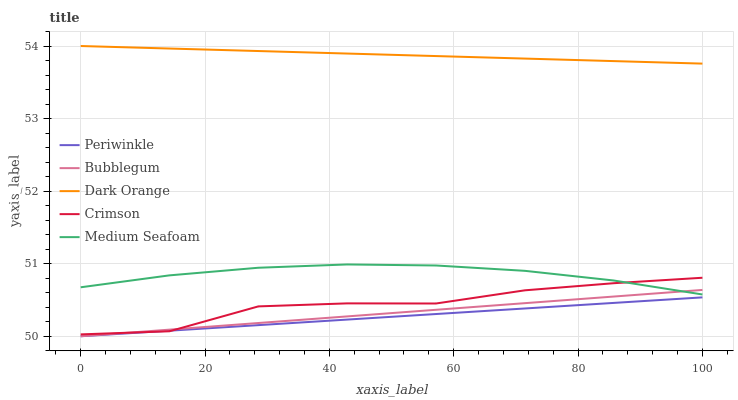Does Periwinkle have the minimum area under the curve?
Answer yes or no. Yes. Does Dark Orange have the maximum area under the curve?
Answer yes or no. Yes. Does Dark Orange have the minimum area under the curve?
Answer yes or no. No. Does Periwinkle have the maximum area under the curve?
Answer yes or no. No. Is Bubblegum the smoothest?
Answer yes or no. Yes. Is Crimson the roughest?
Answer yes or no. Yes. Is Dark Orange the smoothest?
Answer yes or no. No. Is Dark Orange the roughest?
Answer yes or no. No. Does Periwinkle have the lowest value?
Answer yes or no. Yes. Does Dark Orange have the lowest value?
Answer yes or no. No. Does Dark Orange have the highest value?
Answer yes or no. Yes. Does Periwinkle have the highest value?
Answer yes or no. No. Is Medium Seafoam less than Dark Orange?
Answer yes or no. Yes. Is Dark Orange greater than Crimson?
Answer yes or no. Yes. Does Crimson intersect Bubblegum?
Answer yes or no. Yes. Is Crimson less than Bubblegum?
Answer yes or no. No. Is Crimson greater than Bubblegum?
Answer yes or no. No. Does Medium Seafoam intersect Dark Orange?
Answer yes or no. No. 